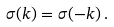<formula> <loc_0><loc_0><loc_500><loc_500>\sigma ( k ) = \sigma ( - k ) \, .</formula> 